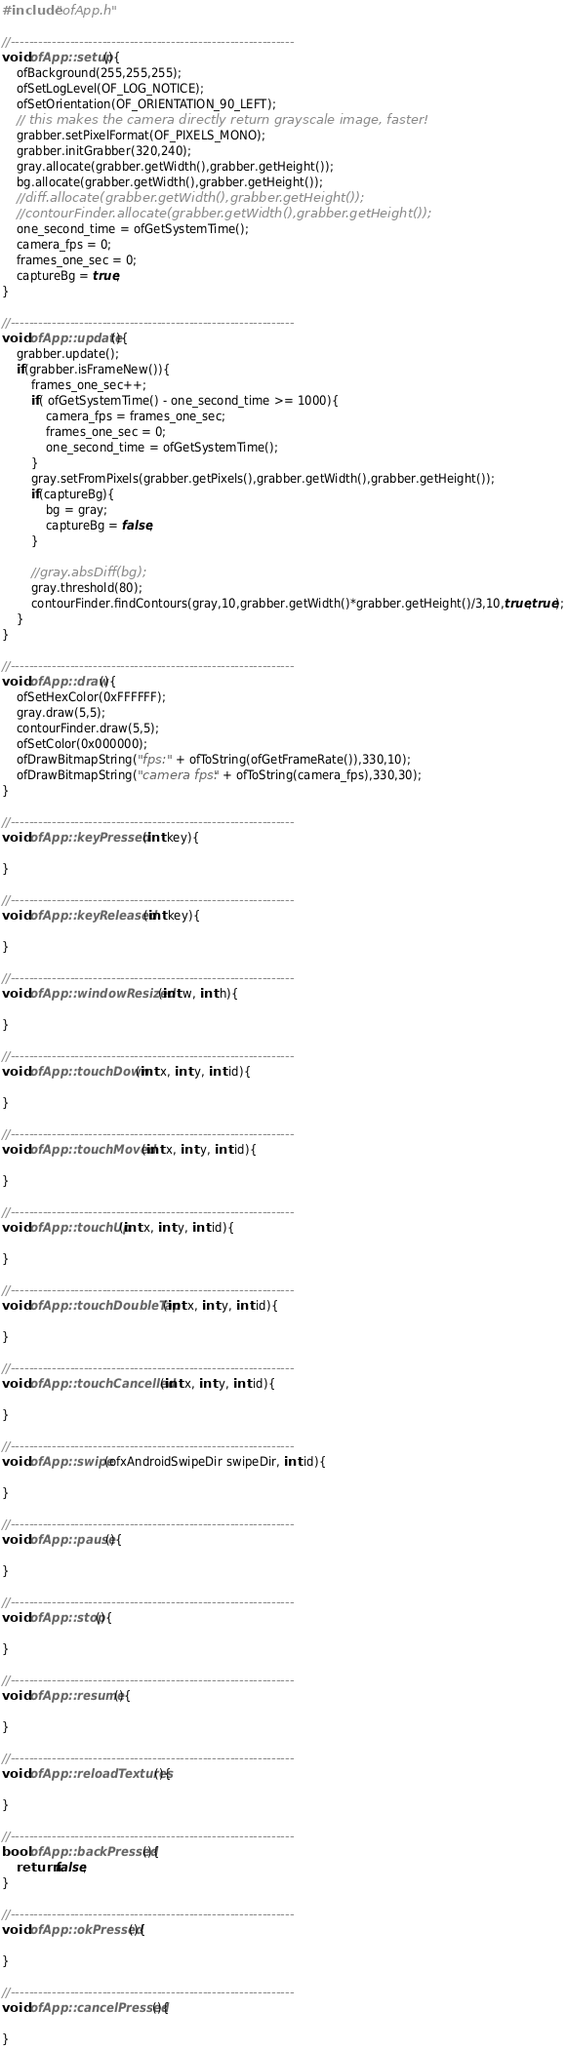Convert code to text. <code><loc_0><loc_0><loc_500><loc_500><_C++_>#include "ofApp.h"

//--------------------------------------------------------------
void ofApp::setup(){
	ofBackground(255,255,255);
	ofSetLogLevel(OF_LOG_NOTICE);
	ofSetOrientation(OF_ORIENTATION_90_LEFT);
	// this makes the camera directly return grayscale image, faster!
	grabber.setPixelFormat(OF_PIXELS_MONO);
	grabber.initGrabber(320,240);
	gray.allocate(grabber.getWidth(),grabber.getHeight());
	bg.allocate(grabber.getWidth(),grabber.getHeight());
	//diff.allocate(grabber.getWidth(),grabber.getHeight());
	//contourFinder.allocate(grabber.getWidth(),grabber.getHeight());
	one_second_time = ofGetSystemTime();
	camera_fps = 0;
	frames_one_sec = 0;
	captureBg = true;
}

//--------------------------------------------------------------
void ofApp::update(){
	grabber.update();
	if(grabber.isFrameNew()){
		frames_one_sec++;
		if( ofGetSystemTime() - one_second_time >= 1000){
			camera_fps = frames_one_sec;
			frames_one_sec = 0;
			one_second_time = ofGetSystemTime();
		}
		gray.setFromPixels(grabber.getPixels(),grabber.getWidth(),grabber.getHeight());
		if(captureBg){
			bg = gray;
			captureBg = false;
		}

		//gray.absDiff(bg);
		gray.threshold(80);
		contourFinder.findContours(gray,10,grabber.getWidth()*grabber.getHeight()/3,10,true,true);
	}
}

//--------------------------------------------------------------
void ofApp::draw(){
	ofSetHexColor(0xFFFFFF);
	gray.draw(5,5);
	contourFinder.draw(5,5);
	ofSetColor(0x000000);
	ofDrawBitmapString("fps: " + ofToString(ofGetFrameRate()),330,10);
	ofDrawBitmapString("camera fps: " + ofToString(camera_fps),330,30);
}

//--------------------------------------------------------------
void ofApp::keyPressed  (int key){ 
	
}

//--------------------------------------------------------------
void ofApp::keyReleased(int key){ 
	
}

//--------------------------------------------------------------
void ofApp::windowResized(int w, int h){

}

//--------------------------------------------------------------
void ofApp::touchDown(int x, int y, int id){

}

//--------------------------------------------------------------
void ofApp::touchMoved(int x, int y, int id){

}

//--------------------------------------------------------------
void ofApp::touchUp(int x, int y, int id){

}

//--------------------------------------------------------------
void ofApp::touchDoubleTap(int x, int y, int id){

}

//--------------------------------------------------------------
void ofApp::touchCancelled(int x, int y, int id){

}

//--------------------------------------------------------------
void ofApp::swipe(ofxAndroidSwipeDir swipeDir, int id){

}

//--------------------------------------------------------------
void ofApp::pause(){

}

//--------------------------------------------------------------
void ofApp::stop(){

}

//--------------------------------------------------------------
void ofApp::resume(){

}

//--------------------------------------------------------------
void ofApp::reloadTextures(){

}

//--------------------------------------------------------------
bool ofApp::backPressed(){
	return false;
}

//--------------------------------------------------------------
void ofApp::okPressed(){

}

//--------------------------------------------------------------
void ofApp::cancelPressed(){

}
</code> 